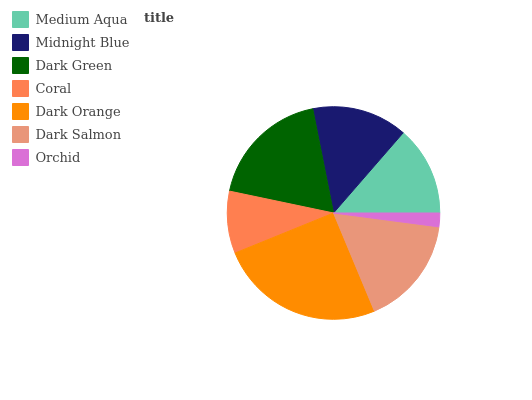Is Orchid the minimum?
Answer yes or no. Yes. Is Dark Orange the maximum?
Answer yes or no. Yes. Is Midnight Blue the minimum?
Answer yes or no. No. Is Midnight Blue the maximum?
Answer yes or no. No. Is Midnight Blue greater than Medium Aqua?
Answer yes or no. Yes. Is Medium Aqua less than Midnight Blue?
Answer yes or no. Yes. Is Medium Aqua greater than Midnight Blue?
Answer yes or no. No. Is Midnight Blue less than Medium Aqua?
Answer yes or no. No. Is Midnight Blue the high median?
Answer yes or no. Yes. Is Midnight Blue the low median?
Answer yes or no. Yes. Is Dark Green the high median?
Answer yes or no. No. Is Orchid the low median?
Answer yes or no. No. 